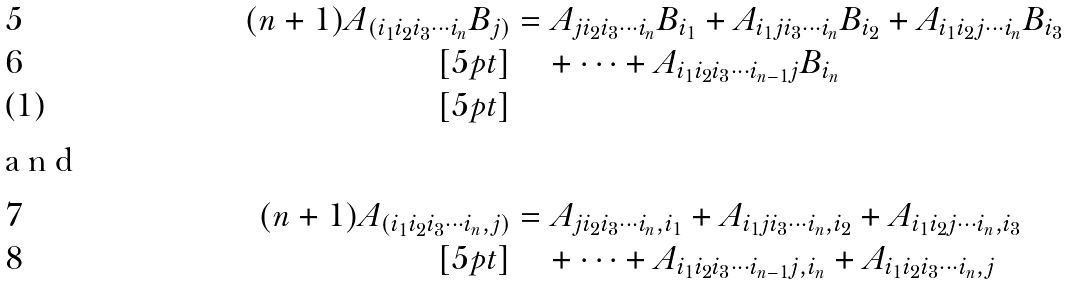Convert formula to latex. <formula><loc_0><loc_0><loc_500><loc_500>( n + 1 ) A _ { ( i _ { 1 } i _ { 2 } i _ { 3 } \cdots i _ { n } } B _ { j ) } & = A _ { j i _ { 2 } i _ { 3 } \cdots i _ { n } } B _ { i _ { 1 } } + A _ { i _ { 1 } j i _ { 3 } \cdots i _ { n } } B _ { i _ { 2 } } + A _ { i _ { 1 } i _ { 2 } j \cdots i _ { n } } B _ { i _ { 3 } } \\ [ 5 p t ] & \quad + \cdots + A _ { i _ { 1 } i _ { 2 } i _ { 3 } \cdots i _ { n - 1 } j } B _ { i _ { n } } \\ [ 5 p t ] \intertext { a n d } ( n + 1 ) A _ { ( i _ { 1 } i _ { 2 } i _ { 3 } \cdots i _ { n } , j ) } & = A _ { j i _ { 2 } i _ { 3 } \cdots i _ { n } , i _ { 1 } } + A _ { i _ { 1 } j i _ { 3 } \cdots i _ { n } , i _ { 2 } } + A _ { i _ { 1 } i _ { 2 } j \cdots i _ { n } , i _ { 3 } } \\ [ 5 p t ] & \quad + \cdots + A _ { i _ { 1 } i _ { 2 } i _ { 3 } \cdots i _ { n - 1 } j , i _ { n } } + A _ { i _ { 1 } i _ { 2 } i _ { 3 } \cdots i _ { n } , j }</formula> 